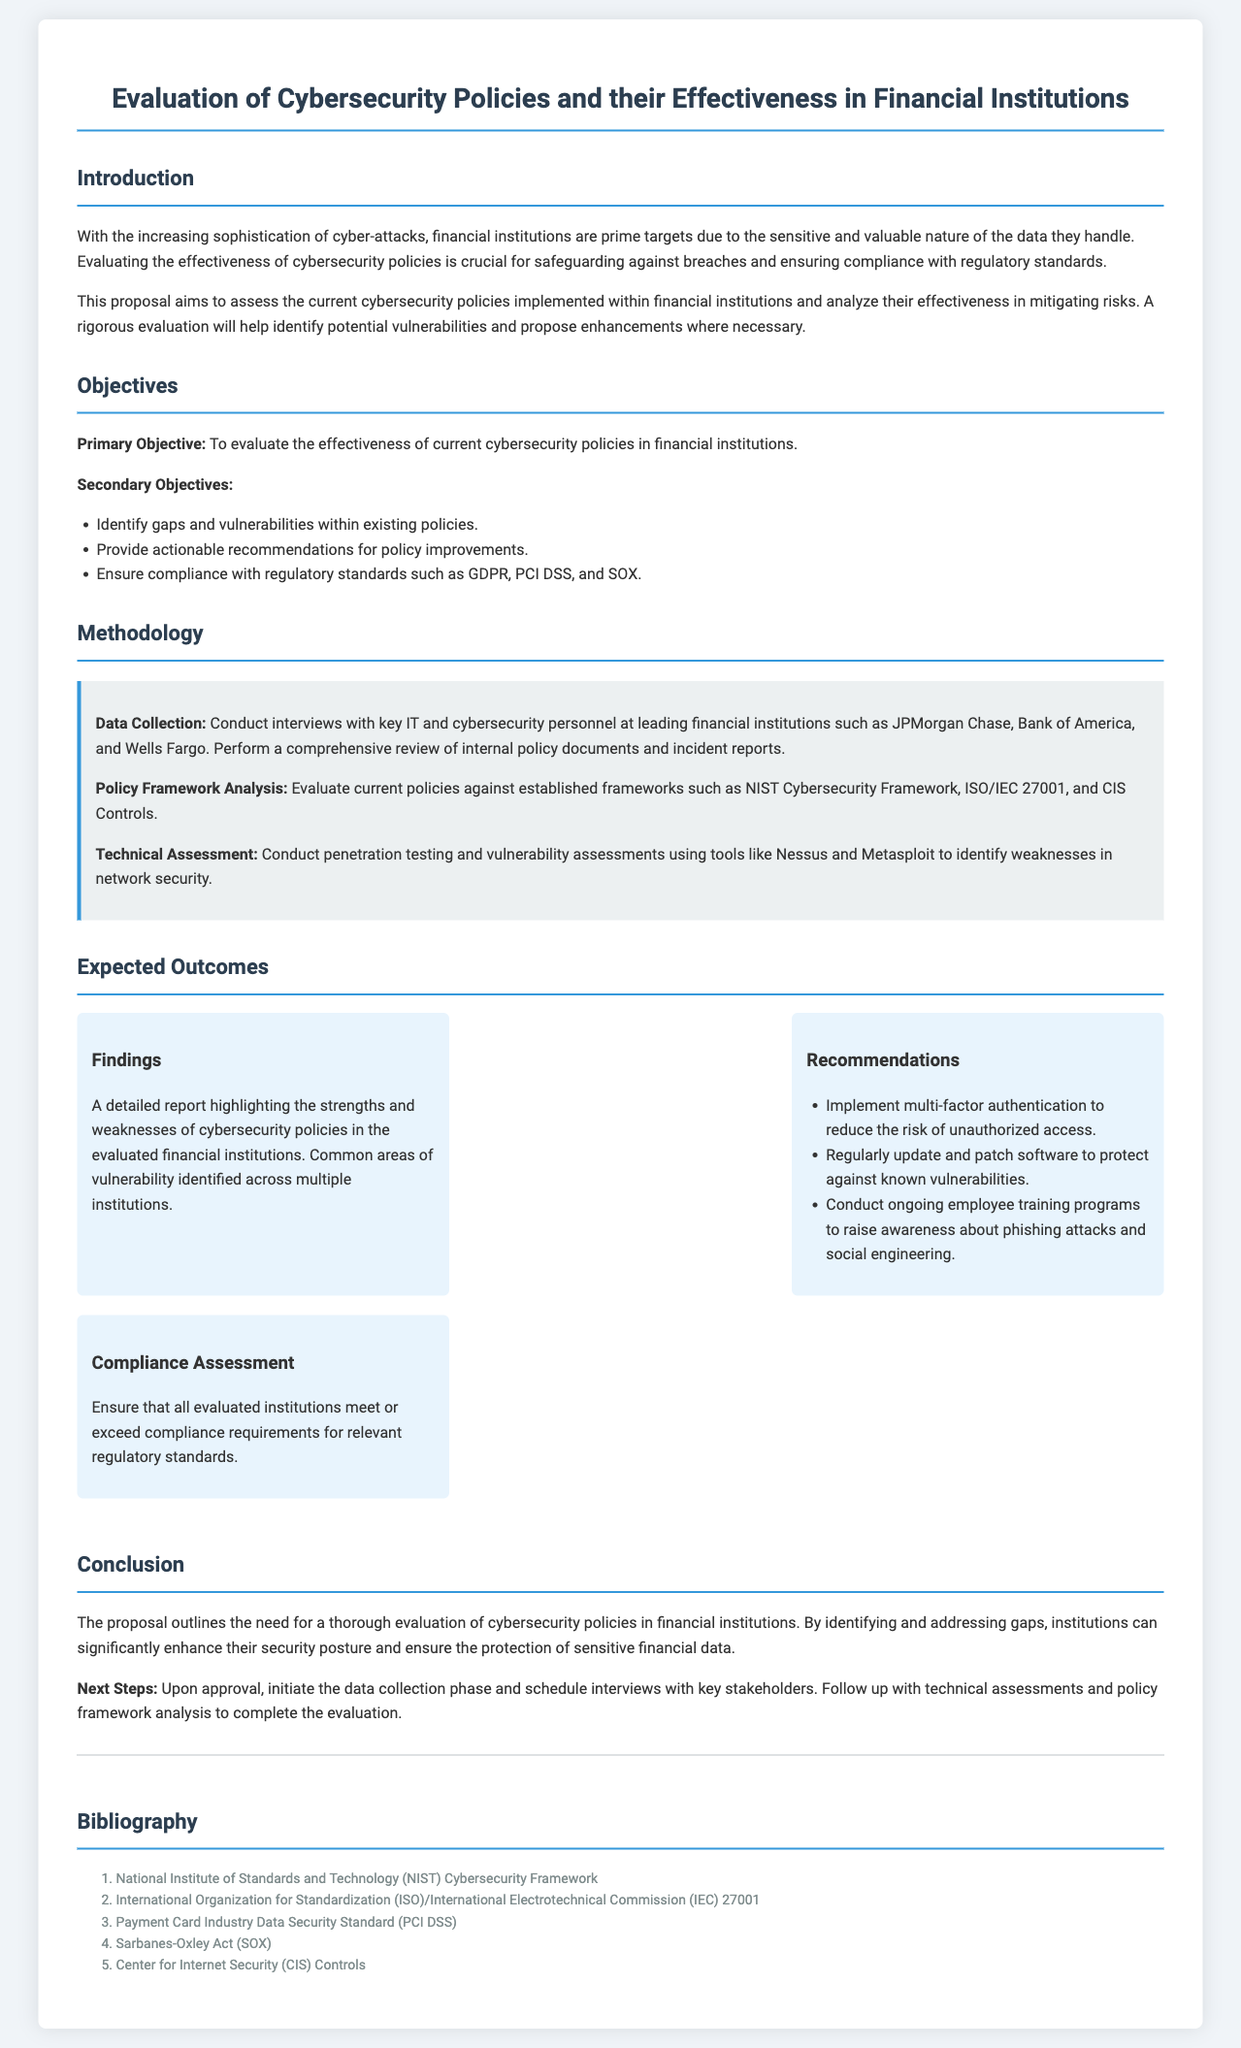What is the primary objective of the proposal? The primary objective is clearly stated in the "Objectives" section, which is to evaluate the effectiveness of current cybersecurity policies in financial institutions.
Answer: To evaluate the effectiveness of current cybersecurity policies in financial institutions What regulatory standards are mentioned in the secondary objectives? The secondary objectives mention specific regulatory standards, which include GDPR, PCI DSS, and SOX.
Answer: GDPR, PCI DSS, and SOX What methodologies will be used for data collection? The "Methodology" section outlines data collection methods such as conducting interviews and reviewing internal policy documents.
Answer: Conduct interviews with key IT and cybersecurity personnel and review internal policy documents What does the "Findings" outcome include? The "Findings" outcome specifies that it will highlight the strengths and weaknesses of cybersecurity policies in evaluated financial institutions.
Answer: A detailed report highlighting the strengths and weaknesses of cybersecurity policies Name one recommended action for improving cybersecurity. The "Recommendations" section lists actions to enhance cybersecurity, one of which is to implement multi-factor authentication.
Answer: Implement multi-factor authentication How many financial institutions will be reviewed? The document does not specify an exact number of financial institutions, but it mentions leading ones such as JPMorgan Chase, Bank of America, and Wells Fargo.
Answer: Leading financial institutions like JPMorgan Chase, Bank of America, and Wells Fargo What is the expected compliance assessment outcome? The expected compliance outcome involves ensuring that all evaluated institutions meet compliance requirements for regulatory standards.
Answer: Ensure that all evaluated institutions meet or exceed compliance requirements 